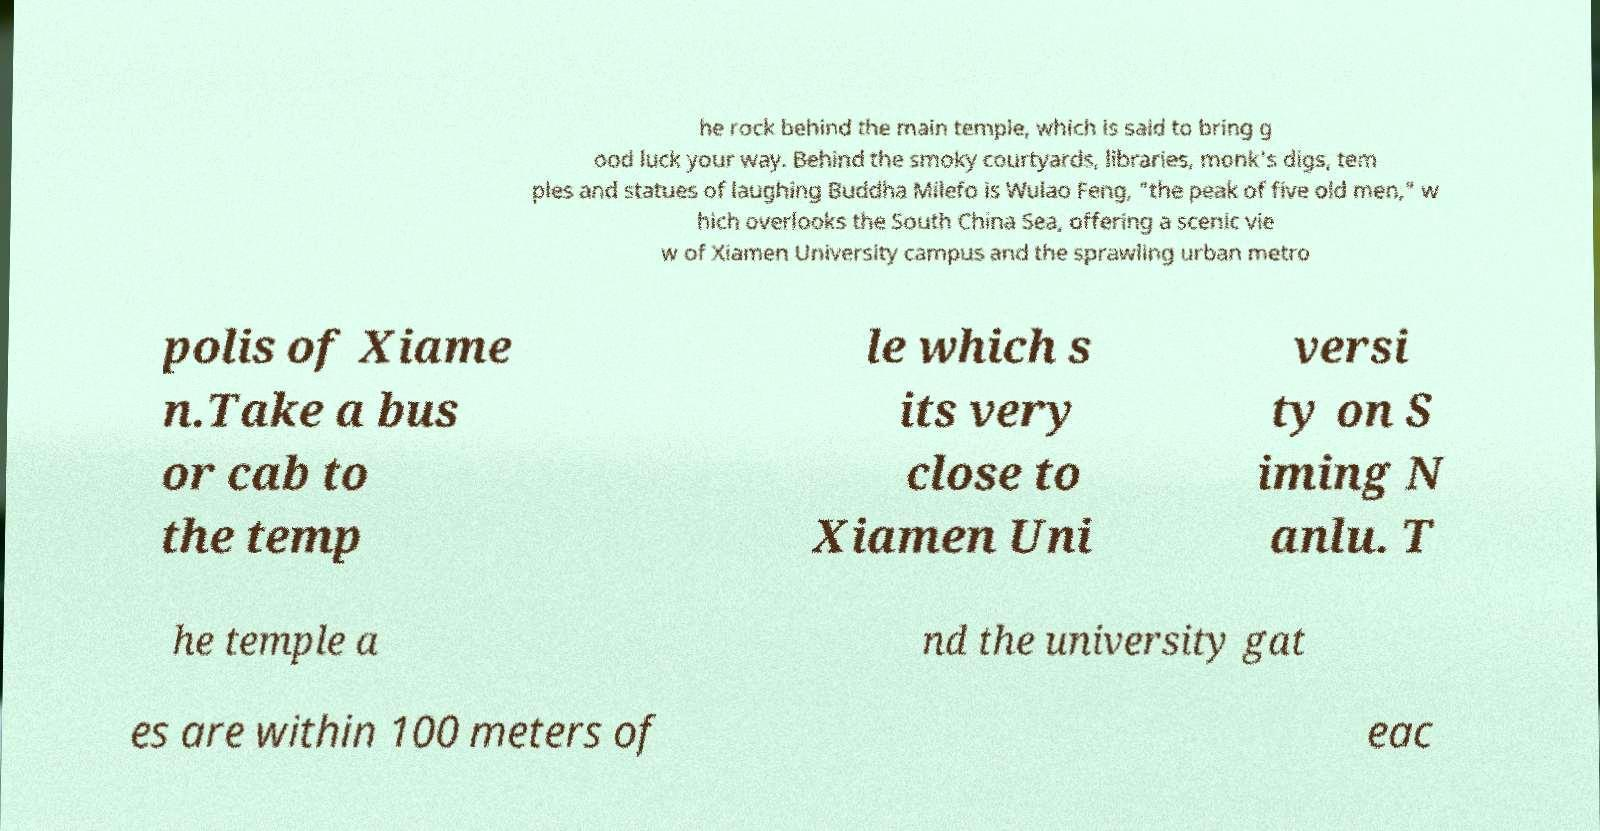I need the written content from this picture converted into text. Can you do that? he rock behind the main temple, which is said to bring g ood luck your way. Behind the smoky courtyards, libraries, monk's digs, tem ples and statues of laughing Buddha Milefo is Wulao Feng, "the peak of five old men," w hich overlooks the South China Sea, offering a scenic vie w of Xiamen University campus and the sprawling urban metro polis of Xiame n.Take a bus or cab to the temp le which s its very close to Xiamen Uni versi ty on S iming N anlu. T he temple a nd the university gat es are within 100 meters of eac 